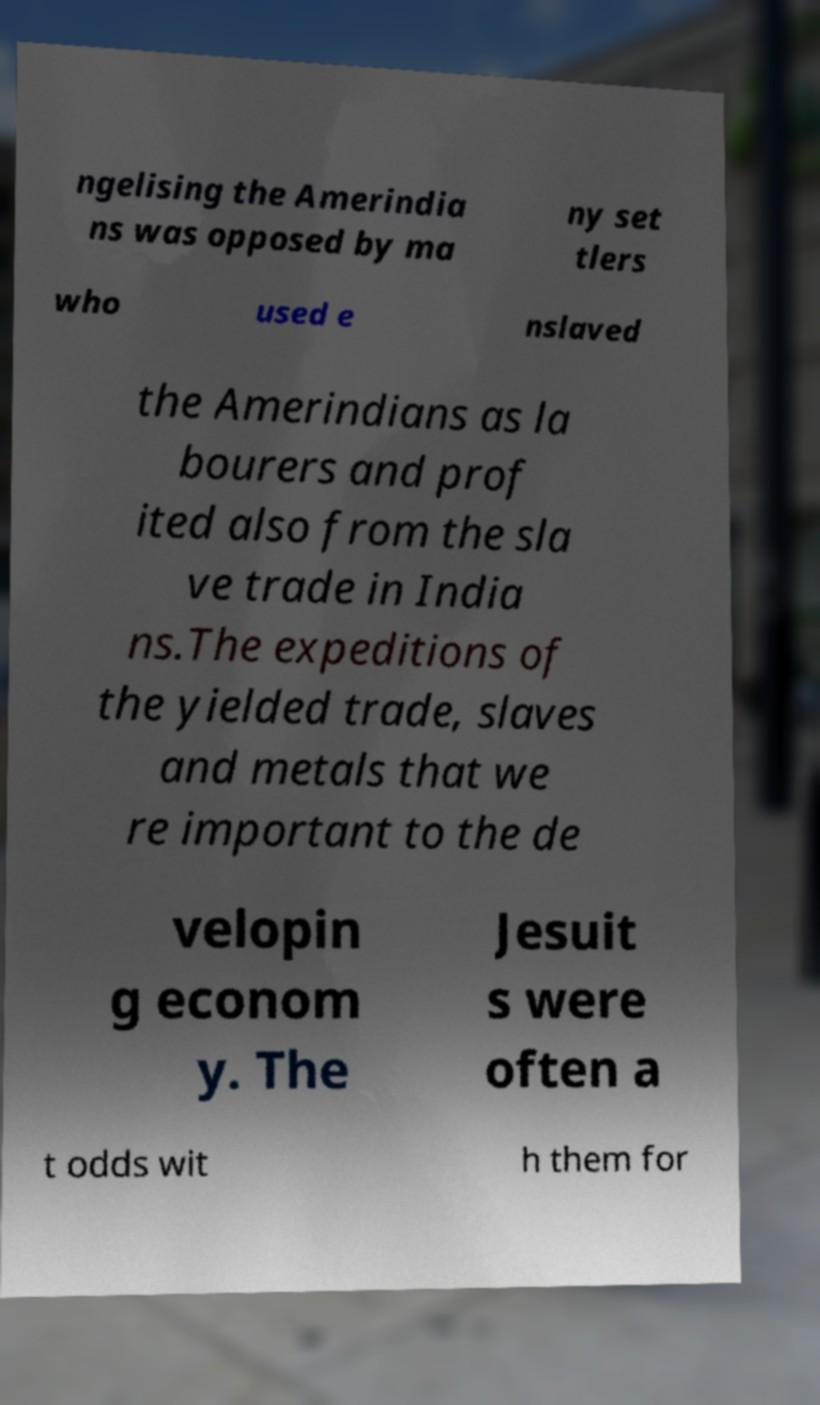Can you read and provide the text displayed in the image?This photo seems to have some interesting text. Can you extract and type it out for me? ngelising the Amerindia ns was opposed by ma ny set tlers who used e nslaved the Amerindians as la bourers and prof ited also from the sla ve trade in India ns.The expeditions of the yielded trade, slaves and metals that we re important to the de velopin g econom y. The Jesuit s were often a t odds wit h them for 